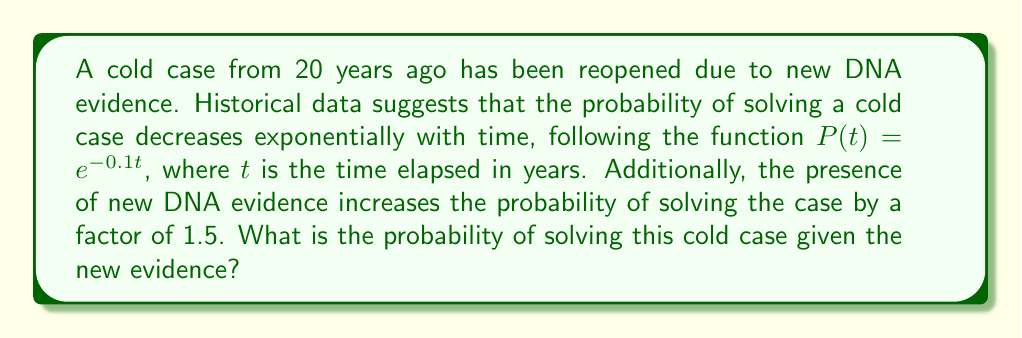Teach me how to tackle this problem. Let's approach this step-by-step:

1) First, we need to calculate the base probability of solving the case without the new evidence:
   
   $P(t) = e^{-0.1t}$
   $t = 20$ years
   
   $P(20) = e^{-0.1(20)} = e^{-2} \approx 0.1353$

2) Now, we need to account for the new DNA evidence. The problem states that this increases the probability by a factor of 1.5:
   
   $P_{new} = 1.5 \times P(20)$

3) Let's calculate the final probability:
   
   $P_{new} = 1.5 \times 0.1353 = 0.2030$

4) Converting to a percentage:
   
   $0.2030 \times 100\% = 20.30\%$

Therefore, the probability of solving this cold case with the new DNA evidence is approximately 20.30%.
Answer: $20.30\%$ 